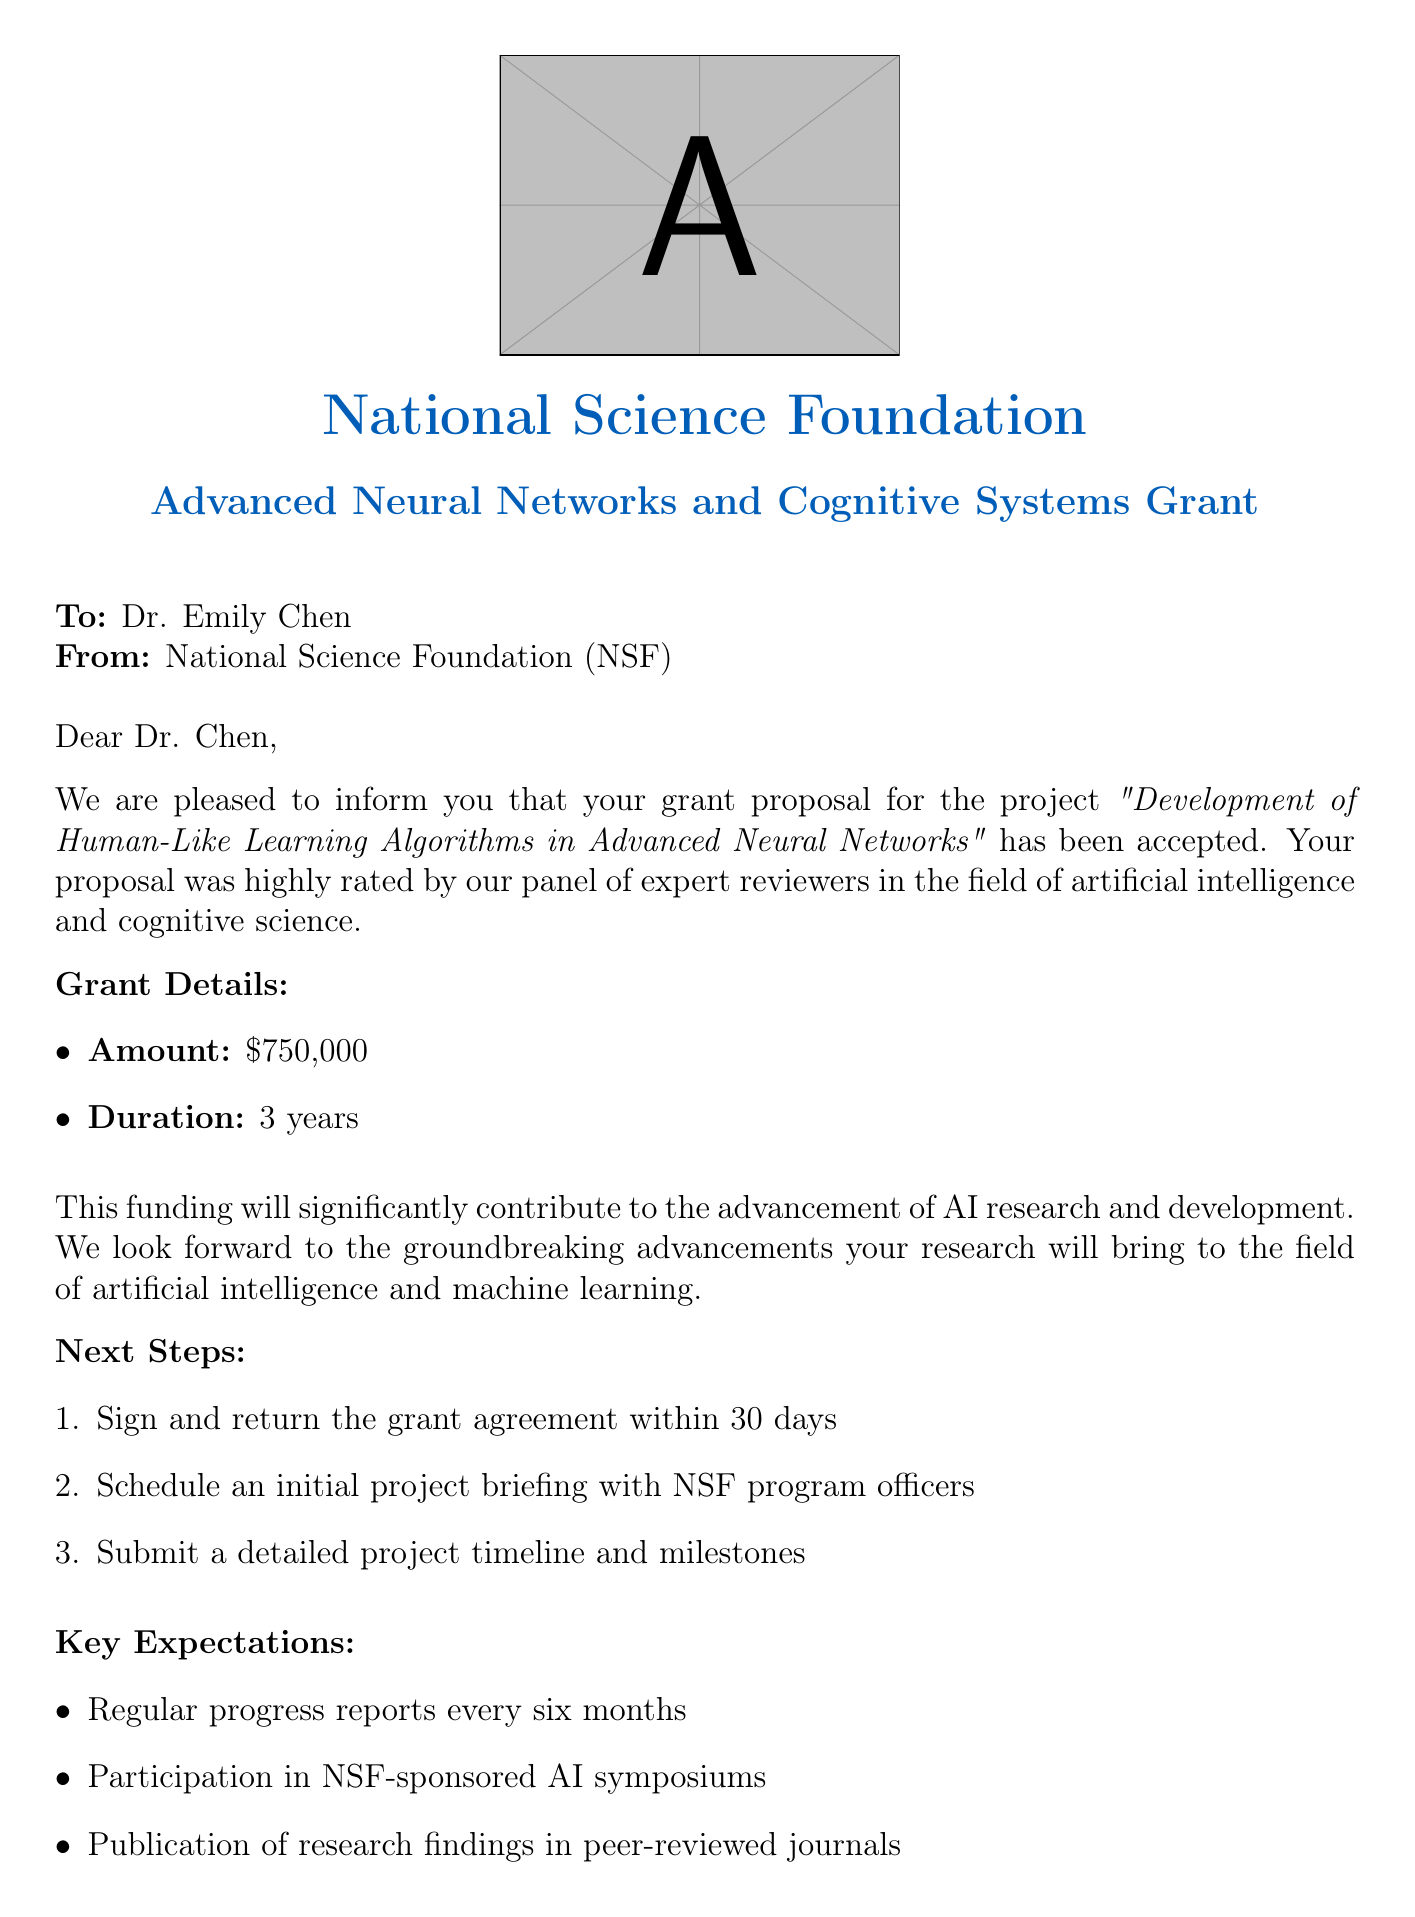What is the grant amount? The grant amount is explicitly stated in the document as $750,000.
Answer: $750,000 Who is the program officer? The document lists Dr. Michael Johnson as the program officer for the grant.
Answer: Dr. Michael Johnson What is the duration of the grant? The duration of the grant is specified as 3 years in the document.
Answer: 3 years What project title is associated with this grant? The project title provided in the grant acceptance email is "Development of Human-Like Learning Algorithms in Advanced Neural Networks."
Answer: Development of Human-Like Learning Algorithms in Advanced Neural Networks What must be submitted within 30 days? The document specifies that the grant agreement must be signed and returned within 30 days.
Answer: Grant agreement What are the key expectations regarding progress reports? The document states that regular progress reports are expected every six months.
Answer: Every six months What is one of the next steps after grant acceptance? One of the next steps mentioned in the document is to schedule an initial project briefing with NSF program officers.
Answer: Schedule an initial project briefing What does the funding aim to contribute towards? The funding is intended to significantly contribute to the advancement of AI research and development.
Answer: Advancement of AI research and development What is the email address for the program officer? The document provides the contact email for Dr. Michael Johnson as mjohnson@nsf.gov.
Answer: mjohnson@nsf.gov 